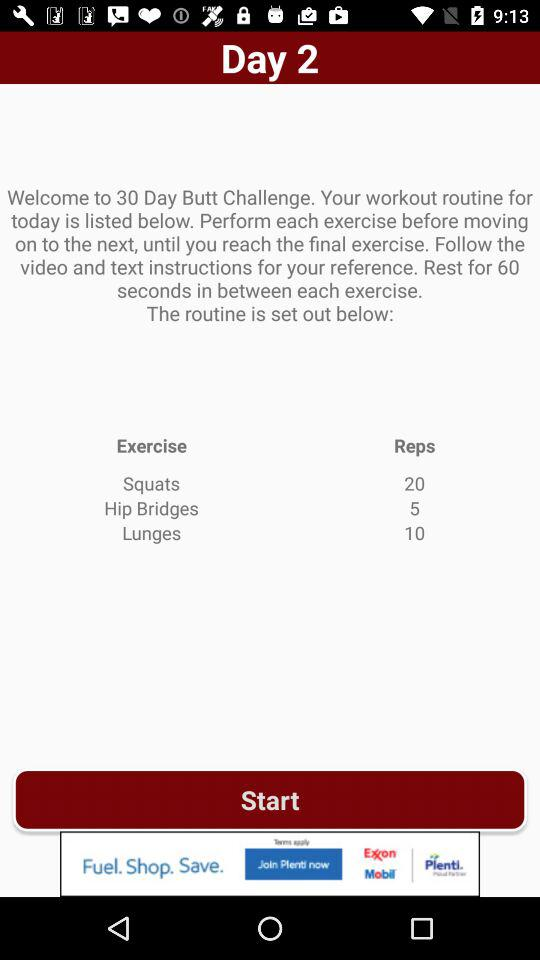What is the count of lunges? The count is 10. 